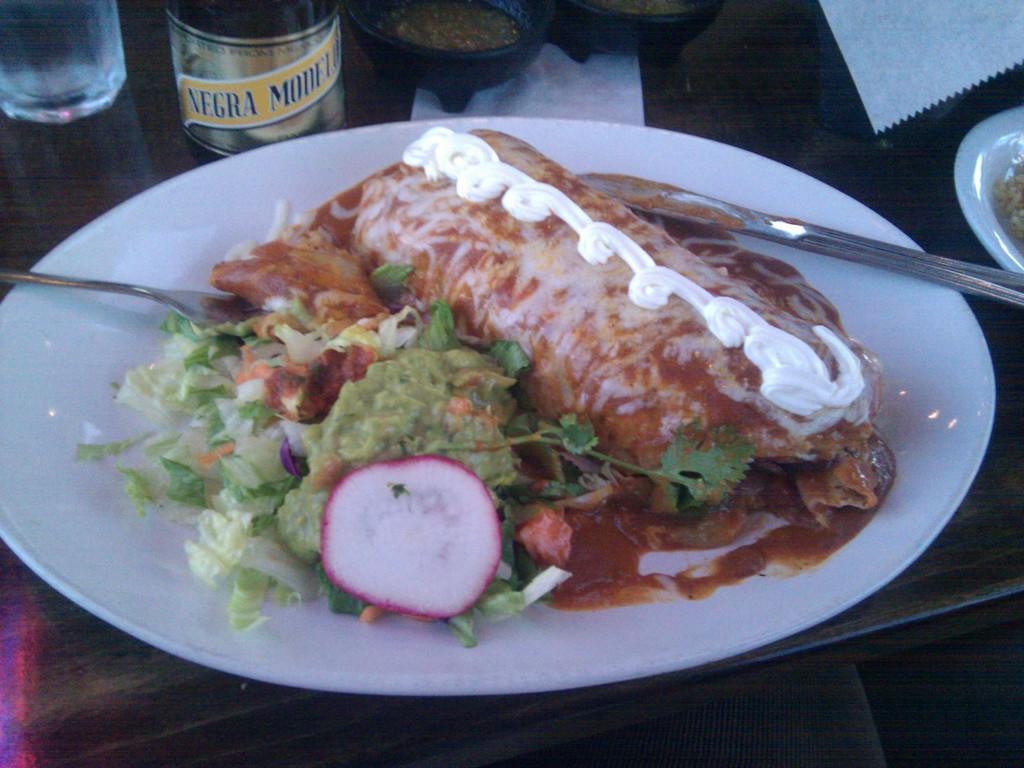Please provide a concise description of this image. In this image there are food items on a plate. There are spoons. Beside the plate there is a glass and there are a few other objects on the table. 